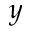Convert formula to latex. <formula><loc_0><loc_0><loc_500><loc_500>y</formula> 